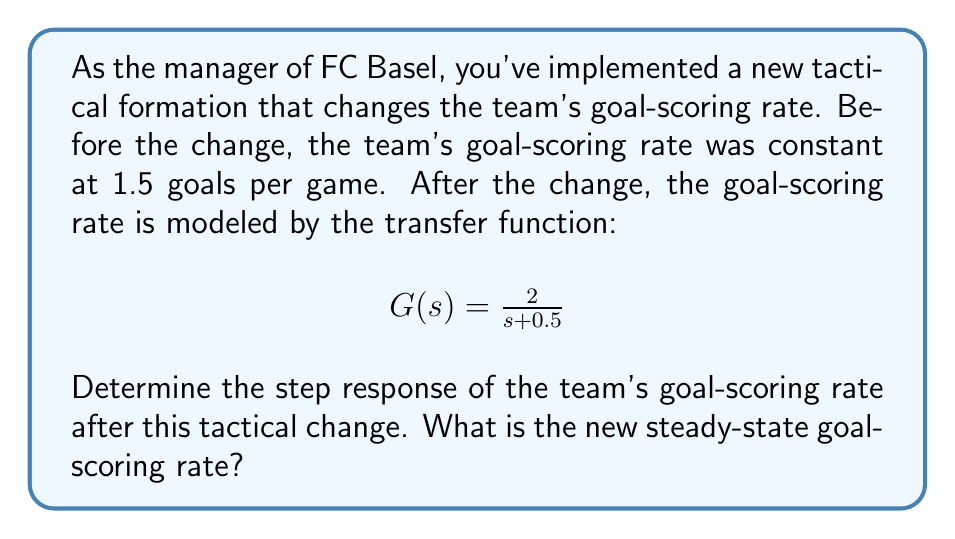What is the answer to this math problem? To solve this problem, we'll use the following steps:

1) The step input represents the tactical change, which can be expressed in the s-domain as $\frac{1.5}{s}$ (1.5 is the initial goal-scoring rate).

2) The overall system response in the s-domain is:

   $$Y(s) = G(s) \cdot \frac{1.5}{s} = \frac{2}{s + 0.5} \cdot \frac{1.5}{s} = \frac{3}{s(s + 0.5)}$$

3) To find the time-domain response, we need to perform inverse Laplace transform. First, let's use partial fraction decomposition:

   $$\frac{3}{s(s + 0.5)} = \frac{A}{s} + \frac{B}{s + 0.5}$$

4) Solving for A and B:

   $$3 = A(s + 0.5) + Bs$$
   $$3 = As + 0.5A + Bs$$

   When $s = 0$: $3 = 0.5A$, so $A = 6$
   When $s = -0.5$: $3 = -6 + 0.5B$, so $B = -6$

5) Therefore, 

   $$Y(s) = \frac{6}{s} - \frac{6}{s + 0.5}$$

6) Taking the inverse Laplace transform:

   $$y(t) = 6 - 6e^{-0.5t}$$

7) As $t \to \infty$, $e^{-0.5t} \to 0$, so the steady-state value is 6.

Therefore, the new steady-state goal-scoring rate is 6 goals per game.
Answer: The step response of the team's goal-scoring rate after the tactical change is:

$$y(t) = 6 - 6e^{-0.5t}$$

The new steady-state goal-scoring rate is 6 goals per game. 